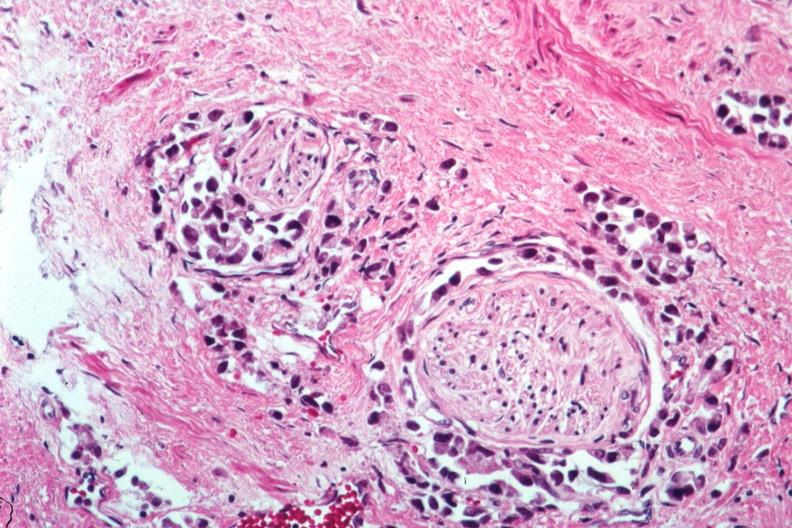s adenocarcinoma present?
Answer the question using a single word or phrase. Yes 